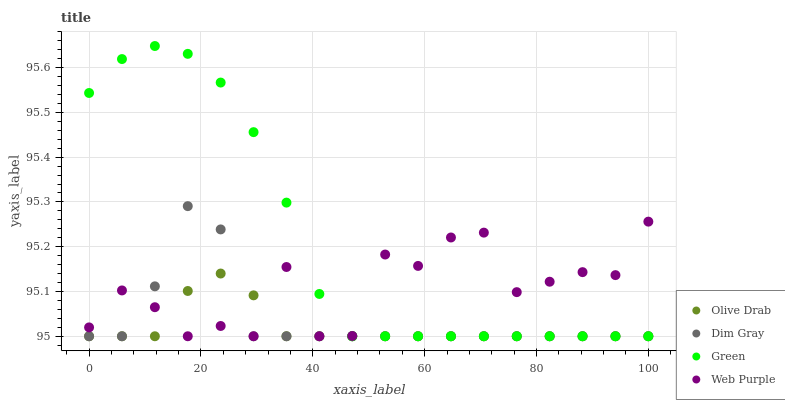Does Olive Drab have the minimum area under the curve?
Answer yes or no. Yes. Does Green have the maximum area under the curve?
Answer yes or no. Yes. Does Dim Gray have the minimum area under the curve?
Answer yes or no. No. Does Dim Gray have the maximum area under the curve?
Answer yes or no. No. Is Olive Drab the smoothest?
Answer yes or no. Yes. Is Web Purple the roughest?
Answer yes or no. Yes. Is Dim Gray the smoothest?
Answer yes or no. No. Is Dim Gray the roughest?
Answer yes or no. No. Does Web Purple have the lowest value?
Answer yes or no. Yes. Does Green have the highest value?
Answer yes or no. Yes. Does Dim Gray have the highest value?
Answer yes or no. No. Does Green intersect Dim Gray?
Answer yes or no. Yes. Is Green less than Dim Gray?
Answer yes or no. No. Is Green greater than Dim Gray?
Answer yes or no. No. 